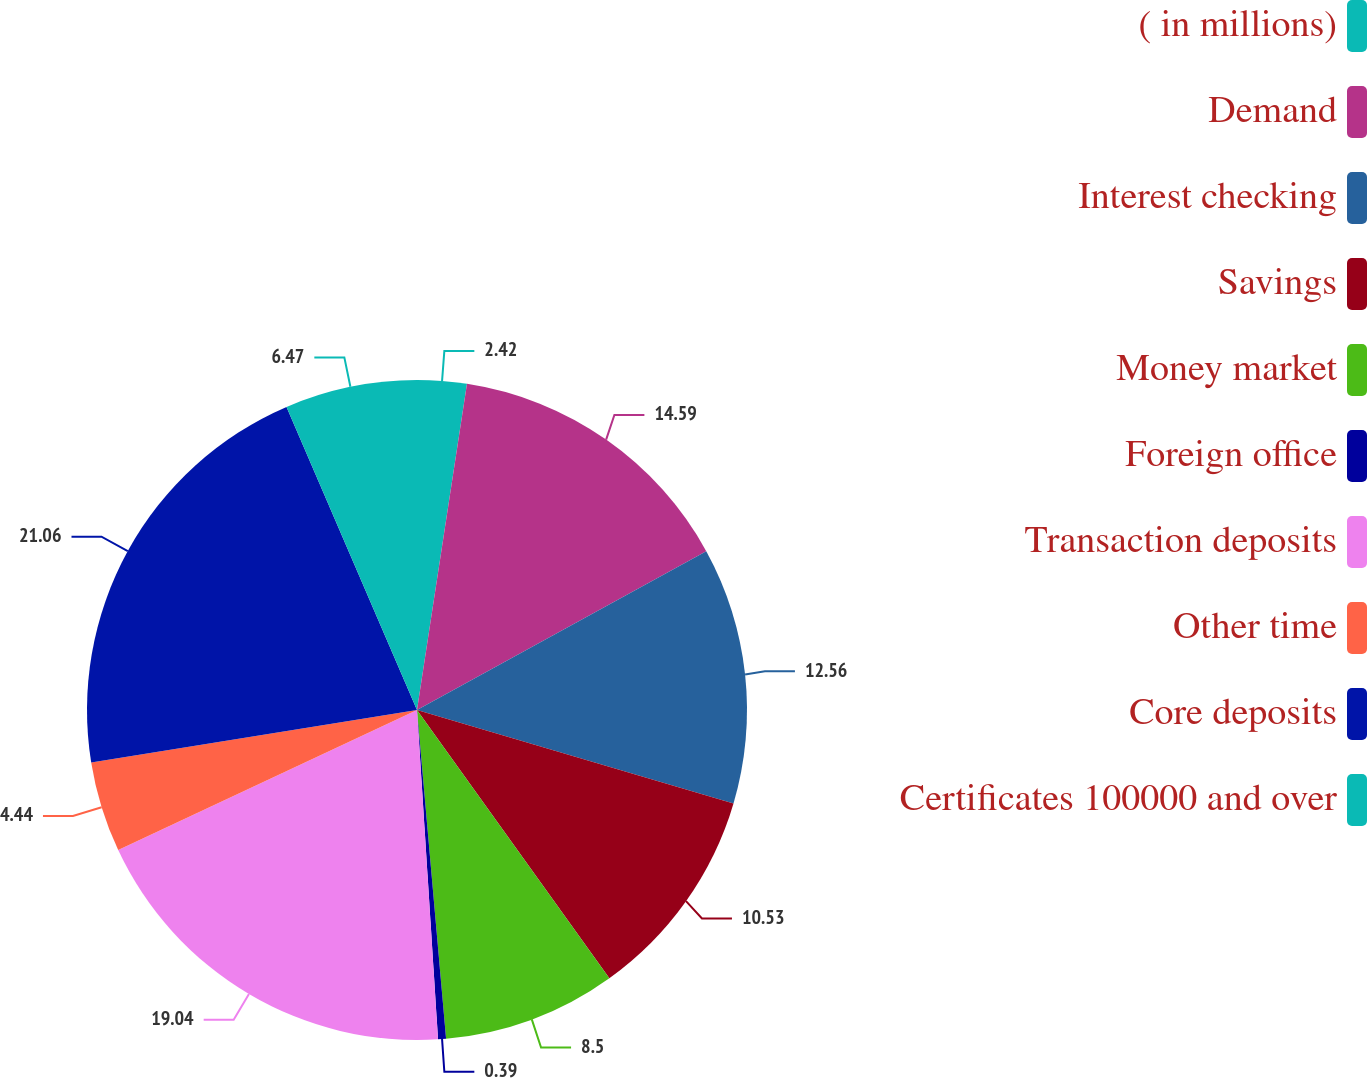Convert chart. <chart><loc_0><loc_0><loc_500><loc_500><pie_chart><fcel>( in millions)<fcel>Demand<fcel>Interest checking<fcel>Savings<fcel>Money market<fcel>Foreign office<fcel>Transaction deposits<fcel>Other time<fcel>Core deposits<fcel>Certificates 100000 and over<nl><fcel>2.42%<fcel>14.59%<fcel>12.56%<fcel>10.53%<fcel>8.5%<fcel>0.39%<fcel>19.04%<fcel>4.44%<fcel>21.07%<fcel>6.47%<nl></chart> 